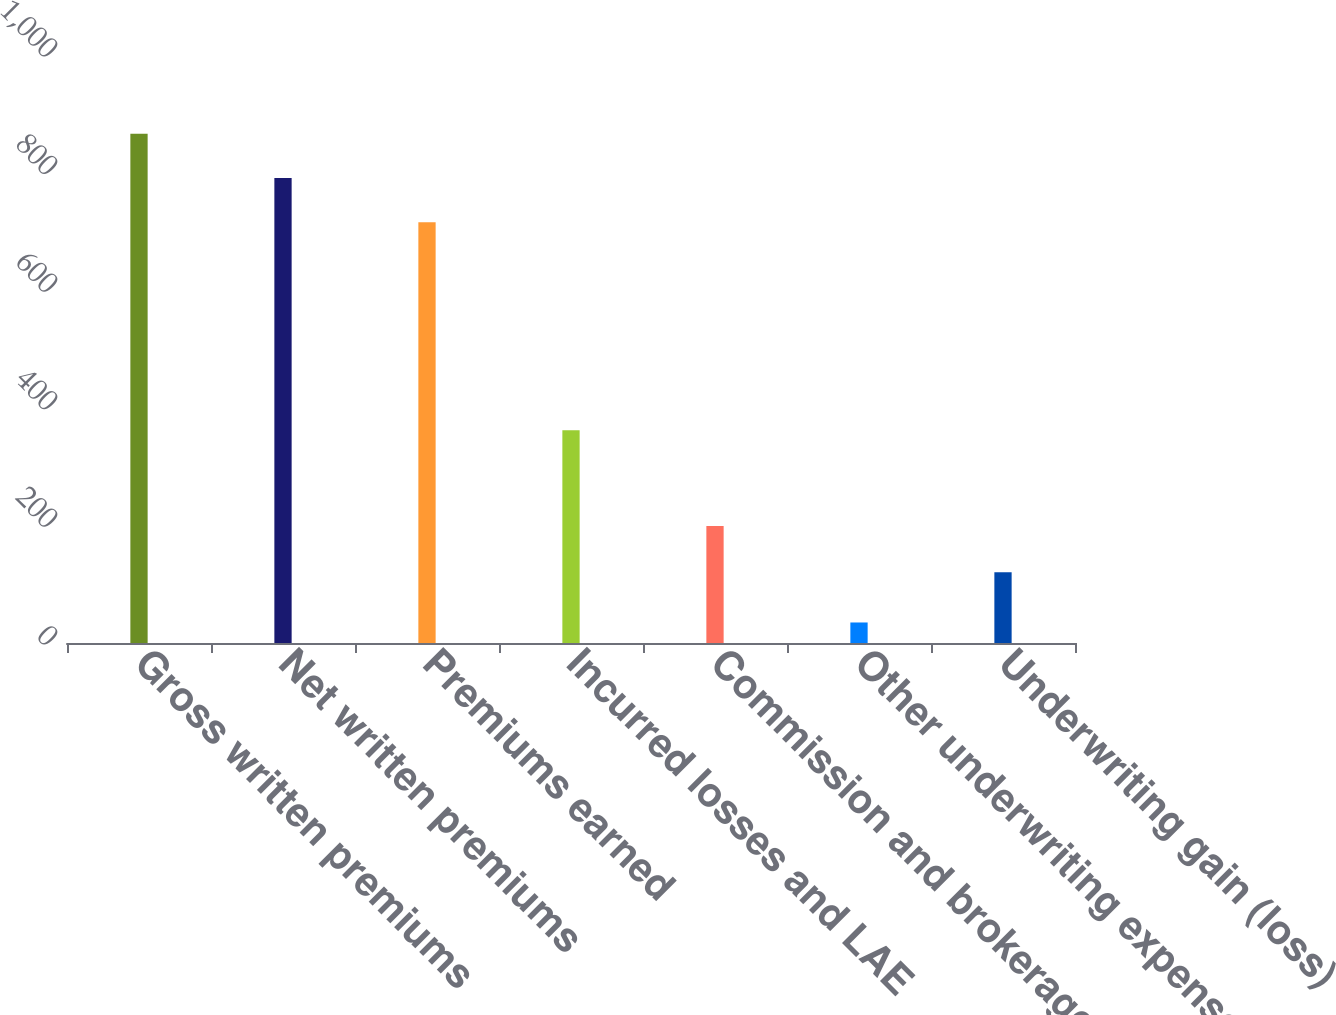Convert chart to OTSL. <chart><loc_0><loc_0><loc_500><loc_500><bar_chart><fcel>Gross written premiums<fcel>Net written premiums<fcel>Premiums earned<fcel>Incurred losses and LAE<fcel>Commission and brokerage<fcel>Other underwriting expenses<fcel>Underwriting gain (loss)<nl><fcel>866<fcel>790.85<fcel>715.7<fcel>361.8<fcel>198.8<fcel>34.9<fcel>120.2<nl></chart> 